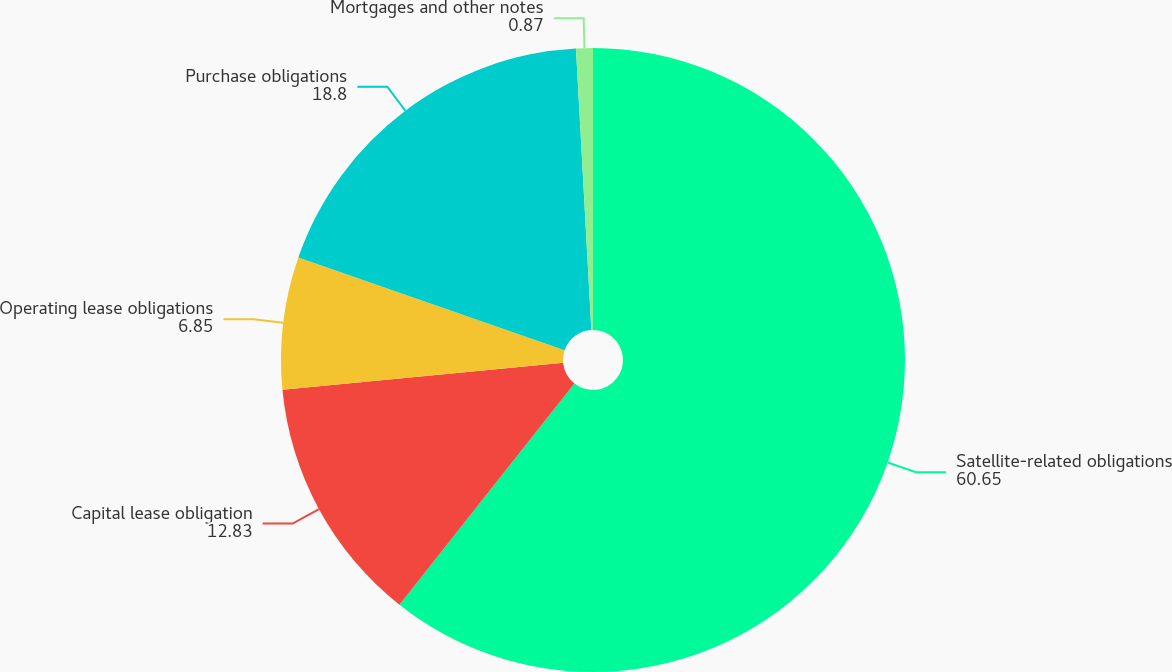Convert chart to OTSL. <chart><loc_0><loc_0><loc_500><loc_500><pie_chart><fcel>Satellite-related obligations<fcel>Capital lease obligation<fcel>Operating lease obligations<fcel>Purchase obligations<fcel>Mortgages and other notes<nl><fcel>60.65%<fcel>12.83%<fcel>6.85%<fcel>18.8%<fcel>0.87%<nl></chart> 